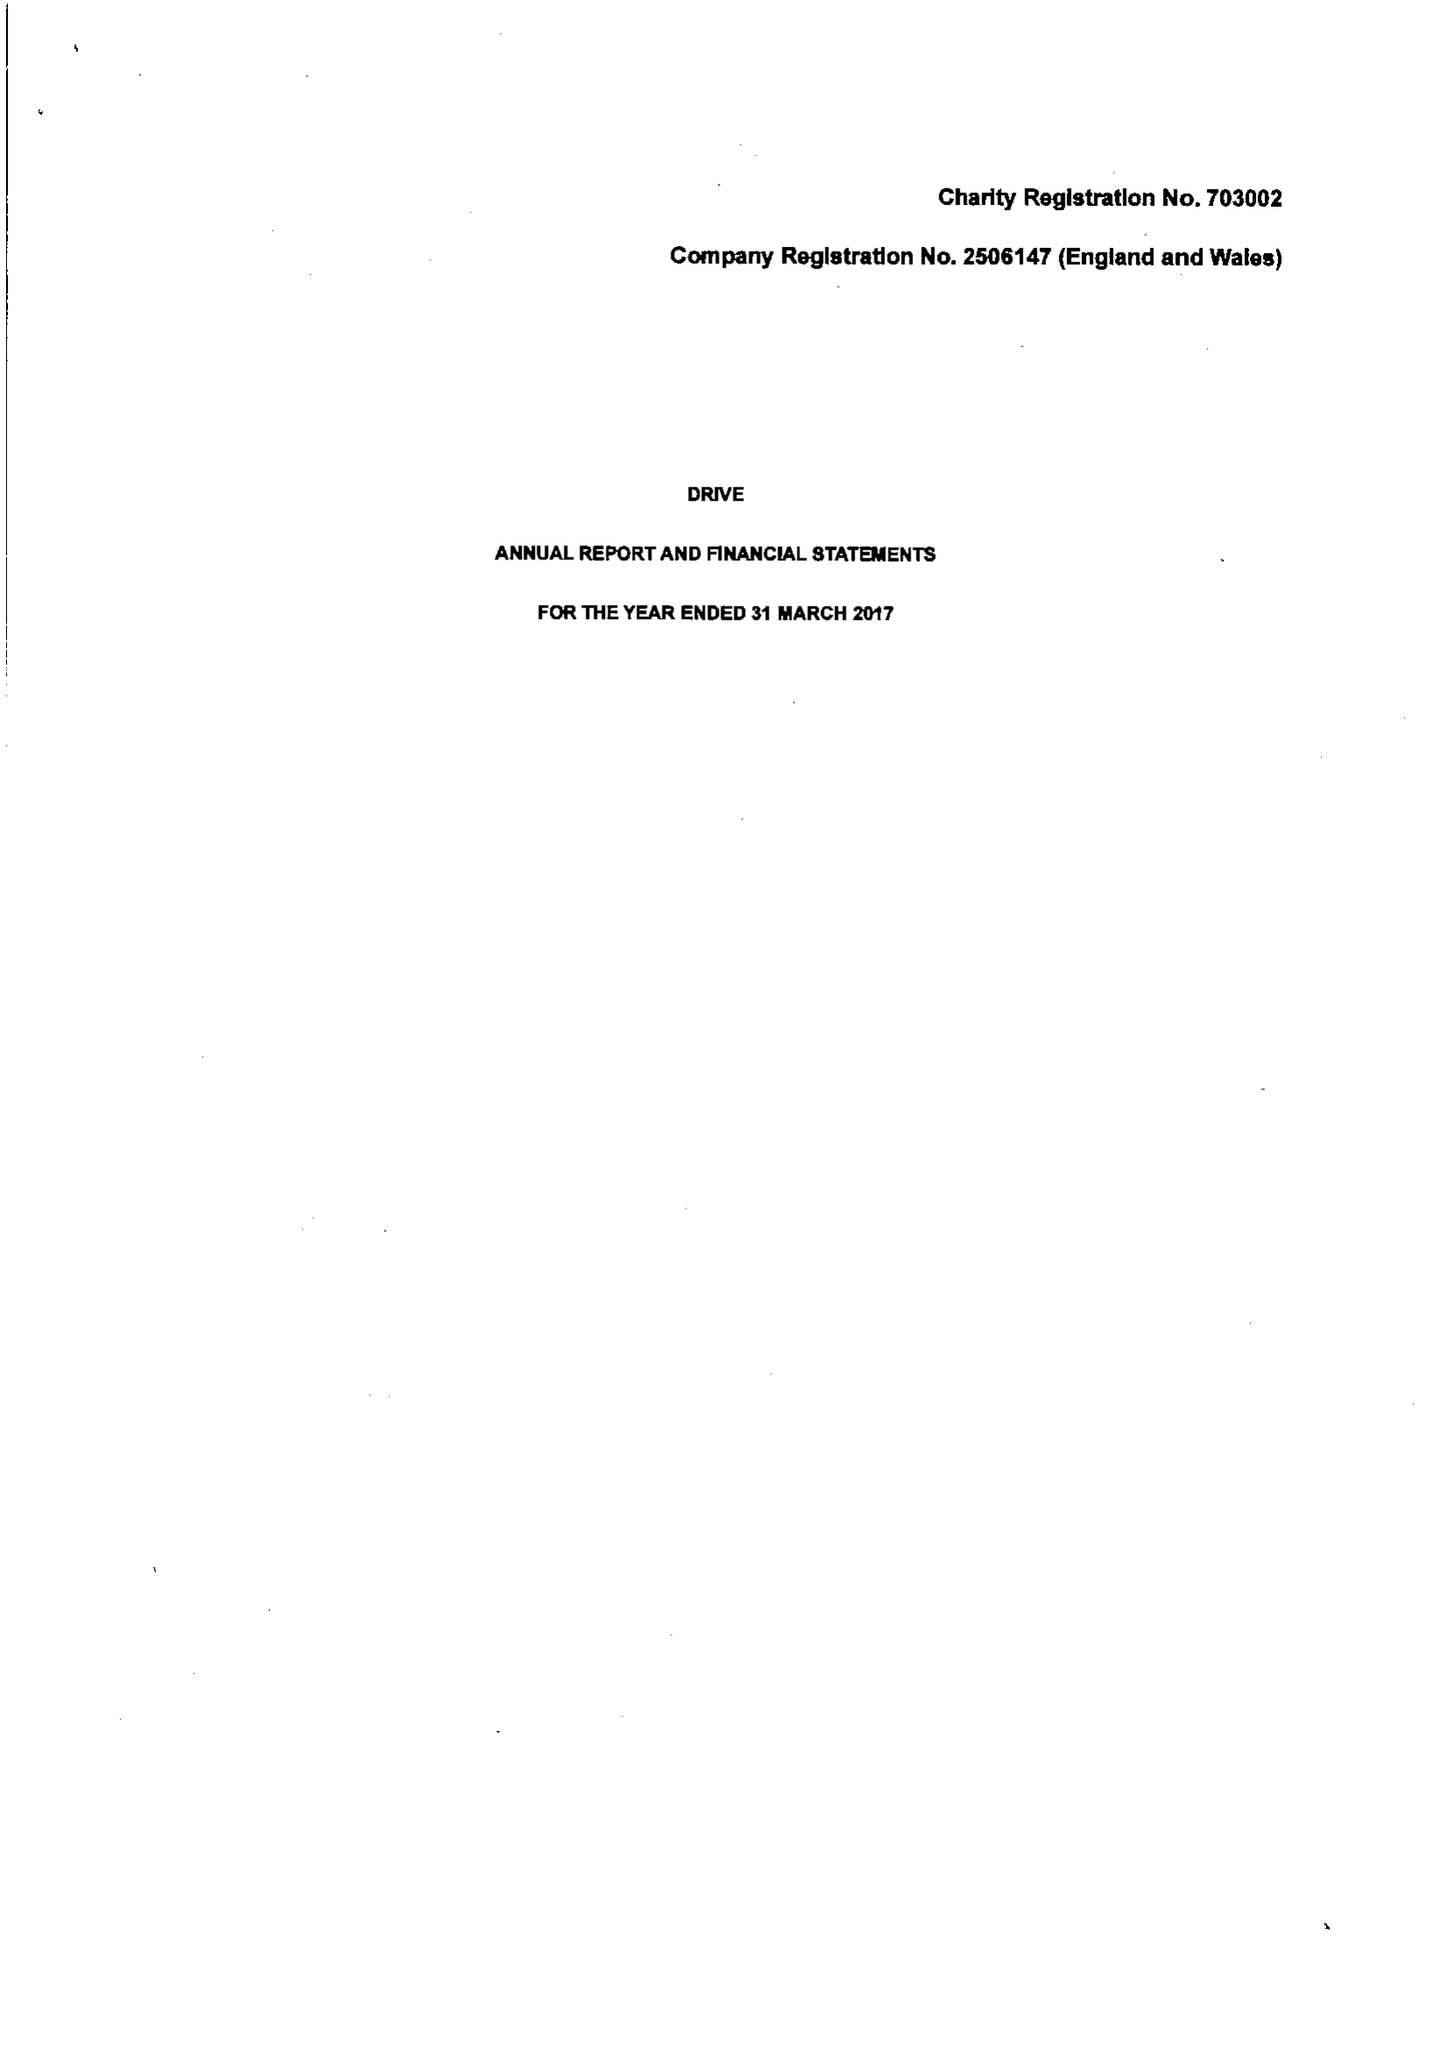What is the value for the address__street_line?
Answer the question using a single word or phrase. CEFN COED 